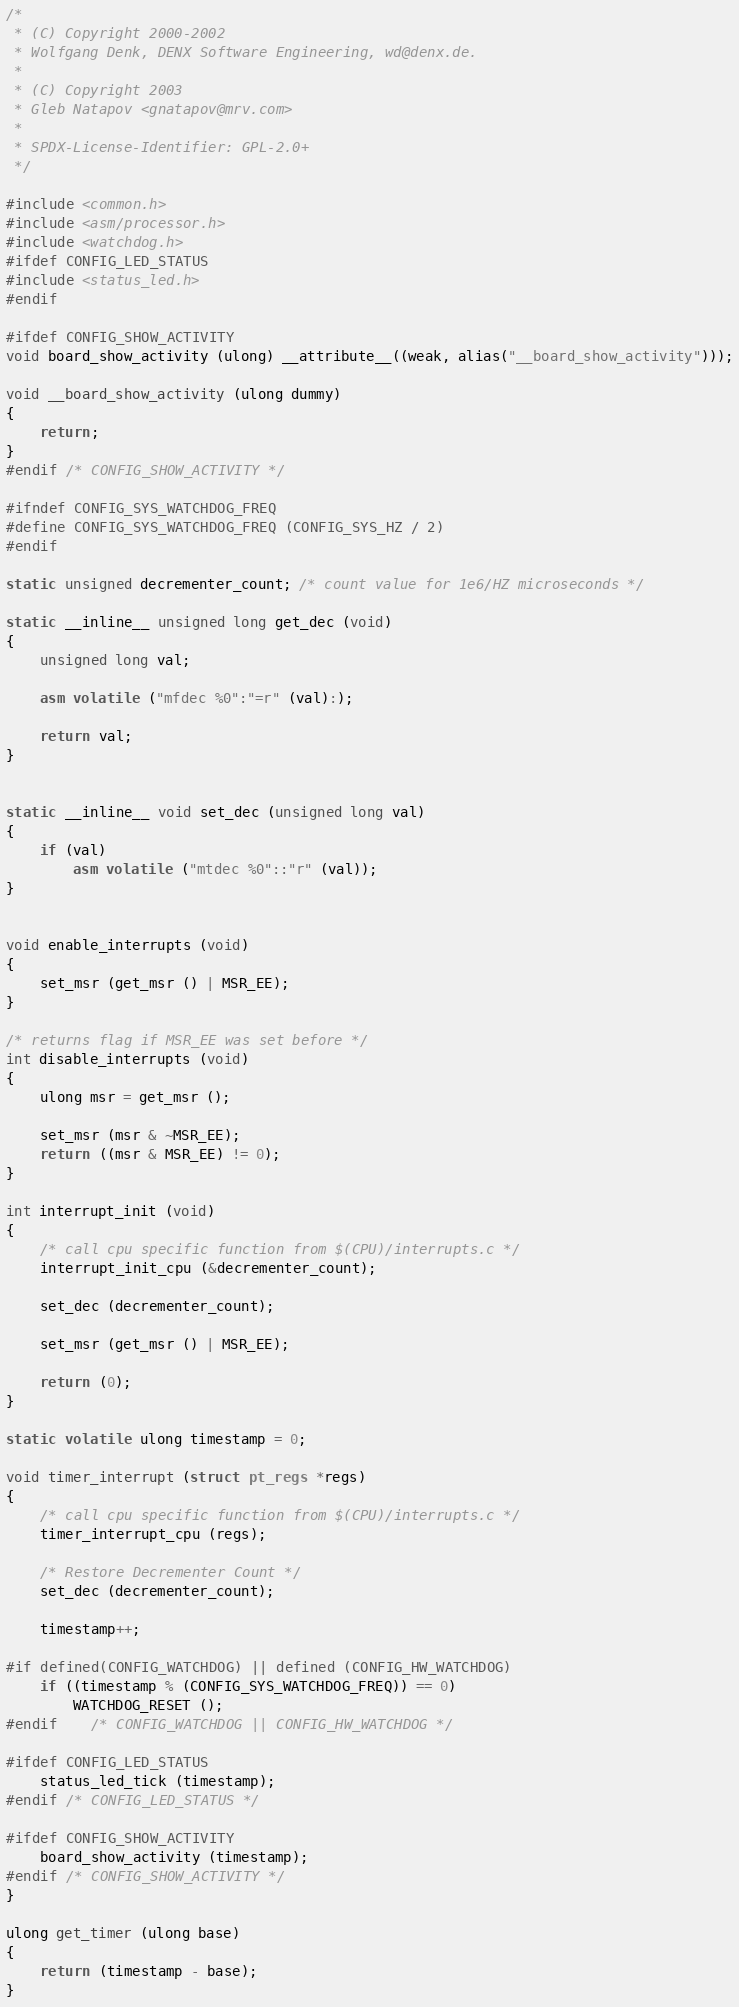<code> <loc_0><loc_0><loc_500><loc_500><_C_>/*
 * (C) Copyright 2000-2002
 * Wolfgang Denk, DENX Software Engineering, wd@denx.de.
 *
 * (C) Copyright 2003
 * Gleb Natapov <gnatapov@mrv.com>
 *
 * SPDX-License-Identifier:	GPL-2.0+
 */

#include <common.h>
#include <asm/processor.h>
#include <watchdog.h>
#ifdef CONFIG_LED_STATUS
#include <status_led.h>
#endif

#ifdef CONFIG_SHOW_ACTIVITY
void board_show_activity (ulong) __attribute__((weak, alias("__board_show_activity")));

void __board_show_activity (ulong dummy)
{
	return;
}
#endif /* CONFIG_SHOW_ACTIVITY */

#ifndef CONFIG_SYS_WATCHDOG_FREQ
#define CONFIG_SYS_WATCHDOG_FREQ (CONFIG_SYS_HZ / 2)
#endif

static unsigned decrementer_count; /* count value for 1e6/HZ microseconds */

static __inline__ unsigned long get_dec (void)
{
	unsigned long val;

	asm volatile ("mfdec %0":"=r" (val):);

	return val;
}


static __inline__ void set_dec (unsigned long val)
{
	if (val)
		asm volatile ("mtdec %0"::"r" (val));
}


void enable_interrupts (void)
{
	set_msr (get_msr () | MSR_EE);
}

/* returns flag if MSR_EE was set before */
int disable_interrupts (void)
{
	ulong msr = get_msr ();

	set_msr (msr & ~MSR_EE);
	return ((msr & MSR_EE) != 0);
}

int interrupt_init (void)
{
	/* call cpu specific function from $(CPU)/interrupts.c */
	interrupt_init_cpu (&decrementer_count);

	set_dec (decrementer_count);

	set_msr (get_msr () | MSR_EE);

	return (0);
}

static volatile ulong timestamp = 0;

void timer_interrupt (struct pt_regs *regs)
{
	/* call cpu specific function from $(CPU)/interrupts.c */
	timer_interrupt_cpu (regs);

	/* Restore Decrementer Count */
	set_dec (decrementer_count);

	timestamp++;

#if defined(CONFIG_WATCHDOG) || defined (CONFIG_HW_WATCHDOG)
	if ((timestamp % (CONFIG_SYS_WATCHDOG_FREQ)) == 0)
		WATCHDOG_RESET ();
#endif    /* CONFIG_WATCHDOG || CONFIG_HW_WATCHDOG */

#ifdef CONFIG_LED_STATUS
	status_led_tick (timestamp);
#endif /* CONFIG_LED_STATUS */

#ifdef CONFIG_SHOW_ACTIVITY
	board_show_activity (timestamp);
#endif /* CONFIG_SHOW_ACTIVITY */
}

ulong get_timer (ulong base)
{
	return (timestamp - base);
}
</code> 